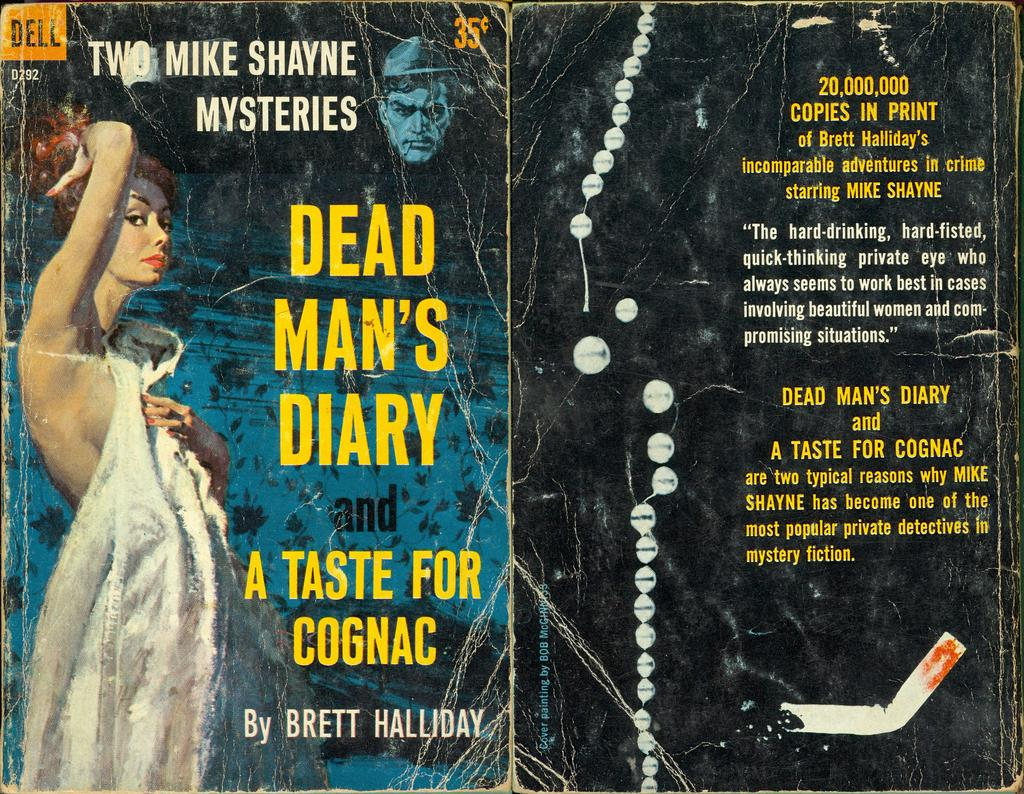<image>
Summarize the visual content of the image. Two Mike Shayne Mysteries have been combined into one book 